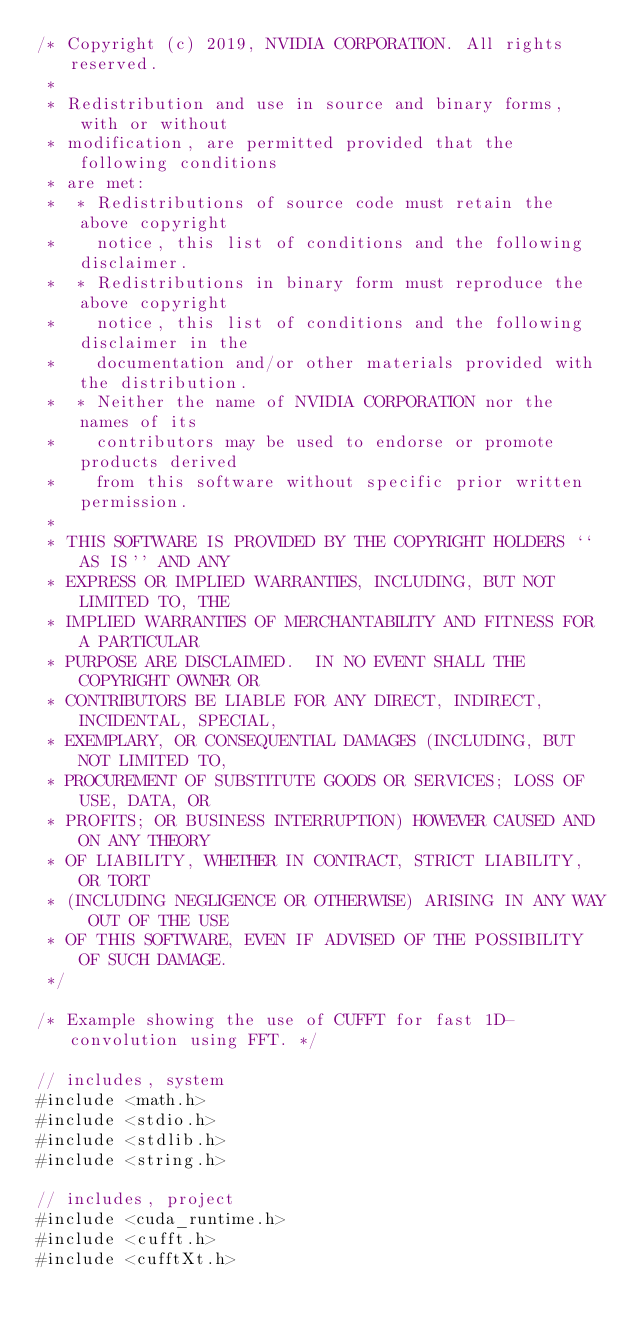<code> <loc_0><loc_0><loc_500><loc_500><_Cuda_>/* Copyright (c) 2019, NVIDIA CORPORATION. All rights reserved.
 *
 * Redistribution and use in source and binary forms, with or without
 * modification, are permitted provided that the following conditions
 * are met:
 *  * Redistributions of source code must retain the above copyright
 *    notice, this list of conditions and the following disclaimer.
 *  * Redistributions in binary form must reproduce the above copyright
 *    notice, this list of conditions and the following disclaimer in the
 *    documentation and/or other materials provided with the distribution.
 *  * Neither the name of NVIDIA CORPORATION nor the names of its
 *    contributors may be used to endorse or promote products derived
 *    from this software without specific prior written permission.
 *
 * THIS SOFTWARE IS PROVIDED BY THE COPYRIGHT HOLDERS ``AS IS'' AND ANY
 * EXPRESS OR IMPLIED WARRANTIES, INCLUDING, BUT NOT LIMITED TO, THE
 * IMPLIED WARRANTIES OF MERCHANTABILITY AND FITNESS FOR A PARTICULAR
 * PURPOSE ARE DISCLAIMED.  IN NO EVENT SHALL THE COPYRIGHT OWNER OR
 * CONTRIBUTORS BE LIABLE FOR ANY DIRECT, INDIRECT, INCIDENTAL, SPECIAL,
 * EXEMPLARY, OR CONSEQUENTIAL DAMAGES (INCLUDING, BUT NOT LIMITED TO,
 * PROCUREMENT OF SUBSTITUTE GOODS OR SERVICES; LOSS OF USE, DATA, OR
 * PROFITS; OR BUSINESS INTERRUPTION) HOWEVER CAUSED AND ON ANY THEORY
 * OF LIABILITY, WHETHER IN CONTRACT, STRICT LIABILITY, OR TORT
 * (INCLUDING NEGLIGENCE OR OTHERWISE) ARISING IN ANY WAY OUT OF THE USE
 * OF THIS SOFTWARE, EVEN IF ADVISED OF THE POSSIBILITY OF SUCH DAMAGE.
 */

/* Example showing the use of CUFFT for fast 1D-convolution using FFT. */

// includes, system
#include <math.h>
#include <stdio.h>
#include <stdlib.h>
#include <string.h>

// includes, project
#include <cuda_runtime.h>
#include <cufft.h>
#include <cufftXt.h></code> 